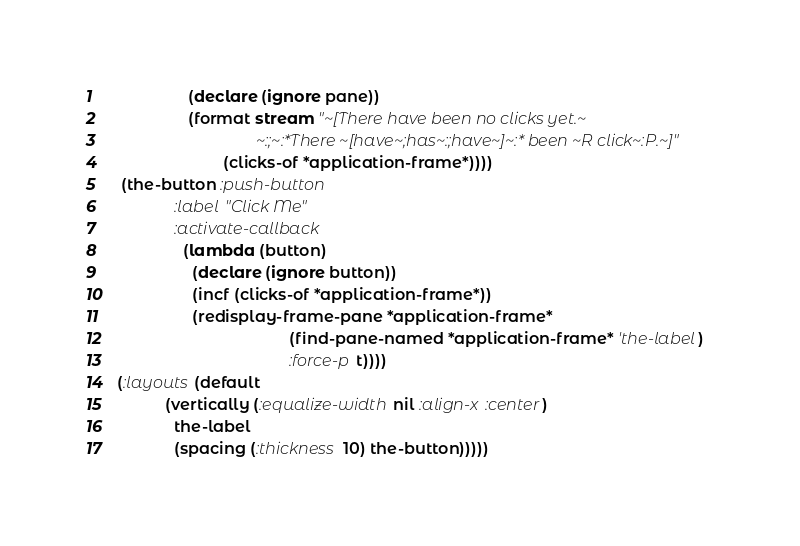Convert code to text. <code><loc_0><loc_0><loc_500><loc_500><_Lisp_>                  (declare (ignore pane))
                  (format stream "~[There have been no clicks yet.~
                                    ~:;~:*There ~[have~;has~:;have~]~:* been ~R click~:P.~]"
                          (clicks-of *application-frame*))))
   (the-button :push-button
               :label "Click Me"
               :activate-callback
                 (lambda (button)
                   (declare (ignore button))
                   (incf (clicks-of *application-frame*))
                   (redisplay-frame-pane *application-frame*
                                         (find-pane-named *application-frame* 'the-label)
                                         :force-p t))))
  (:layouts (default
             (vertically (:equalize-width nil :align-x :center)
               the-label
               (spacing (:thickness 10) the-button)))))
</code> 